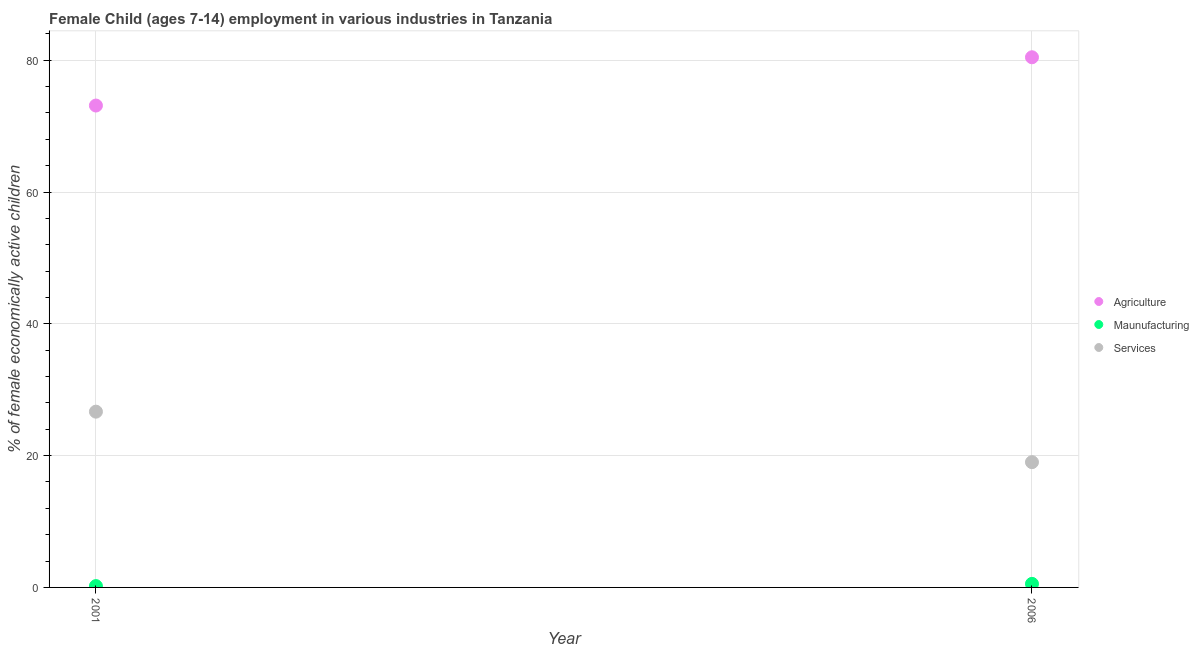How many different coloured dotlines are there?
Make the answer very short. 3. Is the number of dotlines equal to the number of legend labels?
Offer a terse response. Yes. What is the percentage of economically active children in manufacturing in 2001?
Make the answer very short. 0.2. Across all years, what is the maximum percentage of economically active children in manufacturing?
Ensure brevity in your answer.  0.54. Across all years, what is the minimum percentage of economically active children in services?
Give a very brief answer. 19.01. What is the total percentage of economically active children in agriculture in the graph?
Make the answer very short. 153.57. What is the difference between the percentage of economically active children in agriculture in 2001 and that in 2006?
Your answer should be compact. -7.33. What is the difference between the percentage of economically active children in agriculture in 2001 and the percentage of economically active children in services in 2006?
Your answer should be very brief. 54.11. What is the average percentage of economically active children in agriculture per year?
Offer a very short reply. 76.79. In the year 2006, what is the difference between the percentage of economically active children in manufacturing and percentage of economically active children in agriculture?
Keep it short and to the point. -79.91. What is the ratio of the percentage of economically active children in services in 2001 to that in 2006?
Your answer should be very brief. 1.4. Is it the case that in every year, the sum of the percentage of economically active children in agriculture and percentage of economically active children in manufacturing is greater than the percentage of economically active children in services?
Ensure brevity in your answer.  Yes. Is the percentage of economically active children in manufacturing strictly less than the percentage of economically active children in agriculture over the years?
Your answer should be compact. Yes. How many dotlines are there?
Your answer should be compact. 3. What is the difference between two consecutive major ticks on the Y-axis?
Your answer should be compact. 20. Are the values on the major ticks of Y-axis written in scientific E-notation?
Give a very brief answer. No. Does the graph contain any zero values?
Offer a very short reply. No. Does the graph contain grids?
Your response must be concise. Yes. Where does the legend appear in the graph?
Give a very brief answer. Center right. How many legend labels are there?
Provide a succinct answer. 3. What is the title of the graph?
Keep it short and to the point. Female Child (ages 7-14) employment in various industries in Tanzania. What is the label or title of the Y-axis?
Ensure brevity in your answer.  % of female economically active children. What is the % of female economically active children in Agriculture in 2001?
Your answer should be very brief. 73.12. What is the % of female economically active children of Maunufacturing in 2001?
Provide a short and direct response. 0.2. What is the % of female economically active children of Services in 2001?
Provide a succinct answer. 26.67. What is the % of female economically active children in Agriculture in 2006?
Ensure brevity in your answer.  80.45. What is the % of female economically active children of Maunufacturing in 2006?
Offer a terse response. 0.54. What is the % of female economically active children in Services in 2006?
Provide a succinct answer. 19.01. Across all years, what is the maximum % of female economically active children of Agriculture?
Your answer should be very brief. 80.45. Across all years, what is the maximum % of female economically active children of Maunufacturing?
Keep it short and to the point. 0.54. Across all years, what is the maximum % of female economically active children of Services?
Your response must be concise. 26.67. Across all years, what is the minimum % of female economically active children in Agriculture?
Your response must be concise. 73.12. Across all years, what is the minimum % of female economically active children of Maunufacturing?
Make the answer very short. 0.2. Across all years, what is the minimum % of female economically active children in Services?
Your answer should be compact. 19.01. What is the total % of female economically active children of Agriculture in the graph?
Give a very brief answer. 153.57. What is the total % of female economically active children of Maunufacturing in the graph?
Offer a very short reply. 0.74. What is the total % of female economically active children in Services in the graph?
Your response must be concise. 45.68. What is the difference between the % of female economically active children in Agriculture in 2001 and that in 2006?
Provide a succinct answer. -7.33. What is the difference between the % of female economically active children of Maunufacturing in 2001 and that in 2006?
Provide a short and direct response. -0.34. What is the difference between the % of female economically active children in Services in 2001 and that in 2006?
Your answer should be compact. 7.66. What is the difference between the % of female economically active children of Agriculture in 2001 and the % of female economically active children of Maunufacturing in 2006?
Offer a very short reply. 72.58. What is the difference between the % of female economically active children in Agriculture in 2001 and the % of female economically active children in Services in 2006?
Give a very brief answer. 54.11. What is the difference between the % of female economically active children in Maunufacturing in 2001 and the % of female economically active children in Services in 2006?
Offer a terse response. -18.81. What is the average % of female economically active children of Agriculture per year?
Keep it short and to the point. 76.79. What is the average % of female economically active children of Maunufacturing per year?
Your answer should be very brief. 0.37. What is the average % of female economically active children of Services per year?
Offer a terse response. 22.84. In the year 2001, what is the difference between the % of female economically active children of Agriculture and % of female economically active children of Maunufacturing?
Make the answer very short. 72.92. In the year 2001, what is the difference between the % of female economically active children in Agriculture and % of female economically active children in Services?
Offer a terse response. 46.45. In the year 2001, what is the difference between the % of female economically active children of Maunufacturing and % of female economically active children of Services?
Your response must be concise. -26.47. In the year 2006, what is the difference between the % of female economically active children in Agriculture and % of female economically active children in Maunufacturing?
Provide a short and direct response. 79.91. In the year 2006, what is the difference between the % of female economically active children of Agriculture and % of female economically active children of Services?
Keep it short and to the point. 61.44. In the year 2006, what is the difference between the % of female economically active children in Maunufacturing and % of female economically active children in Services?
Offer a very short reply. -18.47. What is the ratio of the % of female economically active children of Agriculture in 2001 to that in 2006?
Keep it short and to the point. 0.91. What is the ratio of the % of female economically active children in Maunufacturing in 2001 to that in 2006?
Your answer should be very brief. 0.38. What is the ratio of the % of female economically active children in Services in 2001 to that in 2006?
Your response must be concise. 1.4. What is the difference between the highest and the second highest % of female economically active children of Agriculture?
Your response must be concise. 7.33. What is the difference between the highest and the second highest % of female economically active children in Maunufacturing?
Provide a succinct answer. 0.34. What is the difference between the highest and the second highest % of female economically active children of Services?
Give a very brief answer. 7.66. What is the difference between the highest and the lowest % of female economically active children of Agriculture?
Your answer should be compact. 7.33. What is the difference between the highest and the lowest % of female economically active children of Maunufacturing?
Offer a terse response. 0.34. What is the difference between the highest and the lowest % of female economically active children of Services?
Make the answer very short. 7.66. 